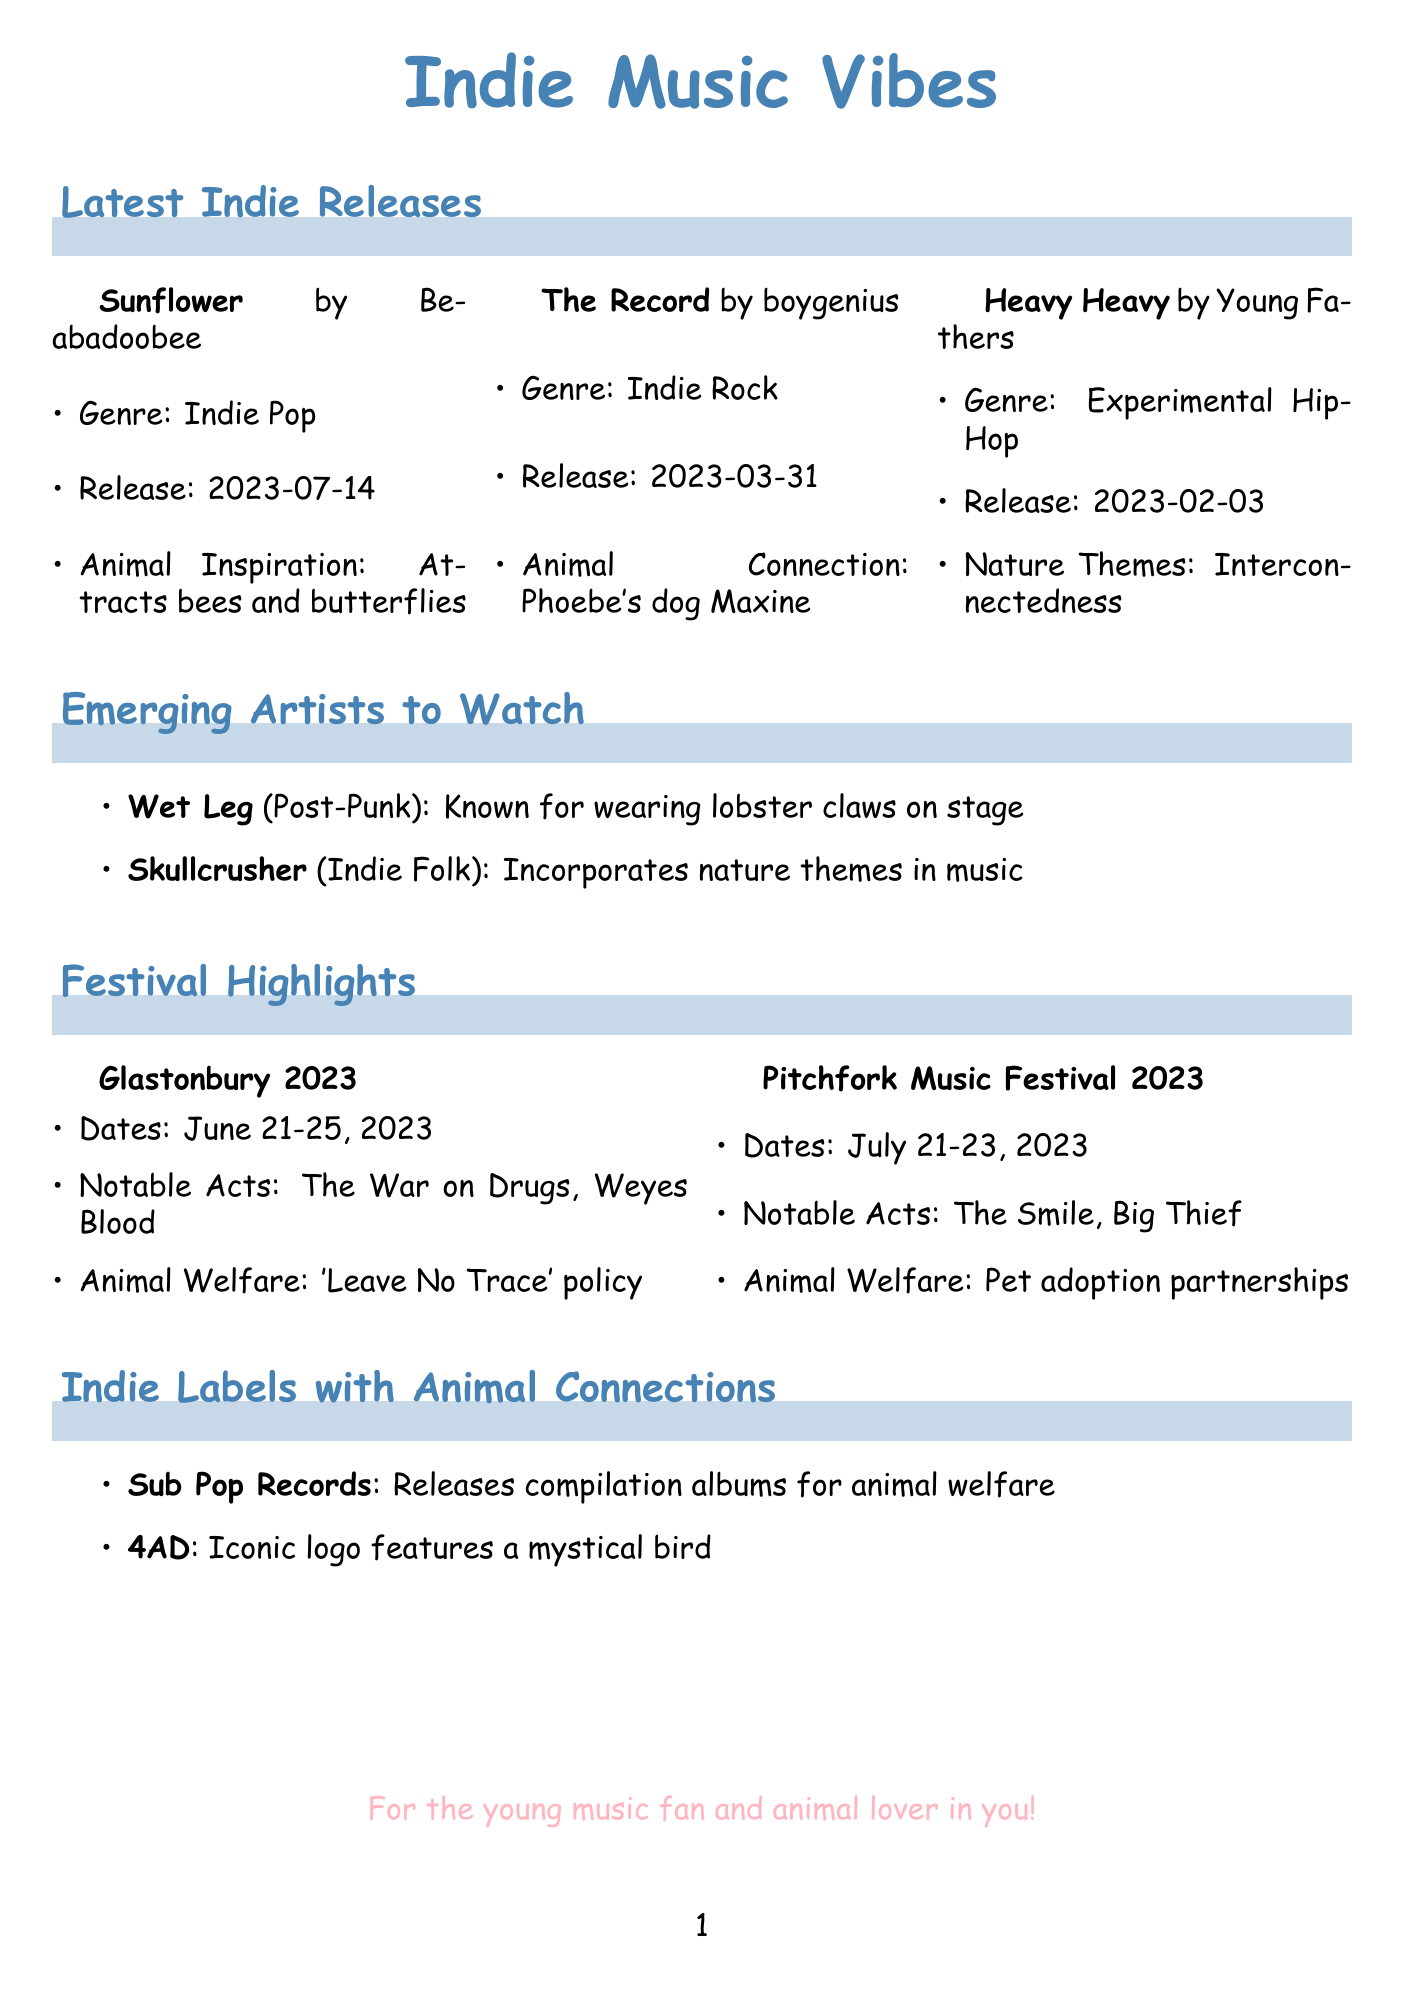What is the release date of "Sunflower"? The release date is mentioned in the document as July 14, 2023.
Answer: July 14, 2023 Who is the artist of "The Record"? The document specifies that "The Record" is by boygenius.
Answer: boygenius What genre does Young Fathers' album "Heavy Heavy" belong to? The genre is indicated in the document as Experimental Hip-Hop.
Answer: Experimental Hip-Hop What animal is often featured in Phoebe Bridgers' social media posts? The document notes that her dog, Maxine, is frequently showcased.
Answer: Maxine Which festival has a 'Leave No Trace' policy? The document states that Glastonbury 2023 has this policy.
Answer: Glastonbury 2023 What notable track is associated with emerging artist Wet Leg? The notable track for Wet Leg is mentioned as "Chaise Longue".
Answer: Chaise Longue Which indie label is based in Seattle, USA? The document lists Sub Pop Records as the label located in Seattle.
Answer: Sub Pop Records What animal-related activity is promoted at the Pitchfork Music Festival? The document mentions that the festival partners with local animal shelters for pet adoption.
Answer: Pet adoption What is the prominent theme in Skullcrusher's music? The document indicates that nature themes are a significant aspect of her music.
Answer: Nature themes 